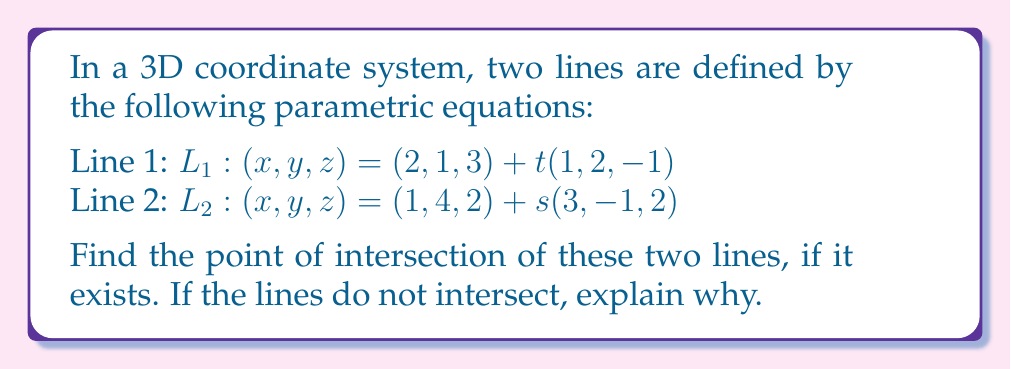What is the answer to this math problem? To find the intersection point of two lines in 3D space, we need to set the equations equal to each other and solve for the parameters t and s:

1) Set the equations equal:
   $(2, 1, 3) + t(1, 2, -1) = (1, 4, 2) + s(3, -1, 2)$

2) This gives us three equations:
   $2 + t = 1 + 3s$
   $1 + 2t = 4 - s$
   $3 - t = 2 + 2s$

3) From the first equation:
   $t = -1 + 3s$ (Equation 1)

4) Substitute this into the second equation:
   $1 + 2(-1 + 3s) = 4 - s$
   $1 - 2 + 6s = 4 - s$
   $7s = 5$
   $s = \frac{5}{7}$

5) Substitute s back into Equation 1:
   $t = -1 + 3(\frac{5}{7}) = -1 + \frac{15}{7} = \frac{8}{7}$

6) Verify using the third equation:
   $3 - \frac{8}{7} = 2 + 2(\frac{5}{7})$
   $\frac{13}{7} = \frac{24}{7}$

   This equality holds, confirming our solution.

7) To find the intersection point, substitute t into L1 or s into L2:
   $(x, y, z) = (2, 1, 3) + \frac{8}{7}(1, 2, -1)$
   $= (2 + \frac{8}{7}, 1 + \frac{16}{7}, 3 - \frac{8}{7})$
   $= (\frac{22}{7}, \frac{23}{7}, \frac{13}{7})$
Answer: $(\frac{22}{7}, \frac{23}{7}, \frac{13}{7})$ 